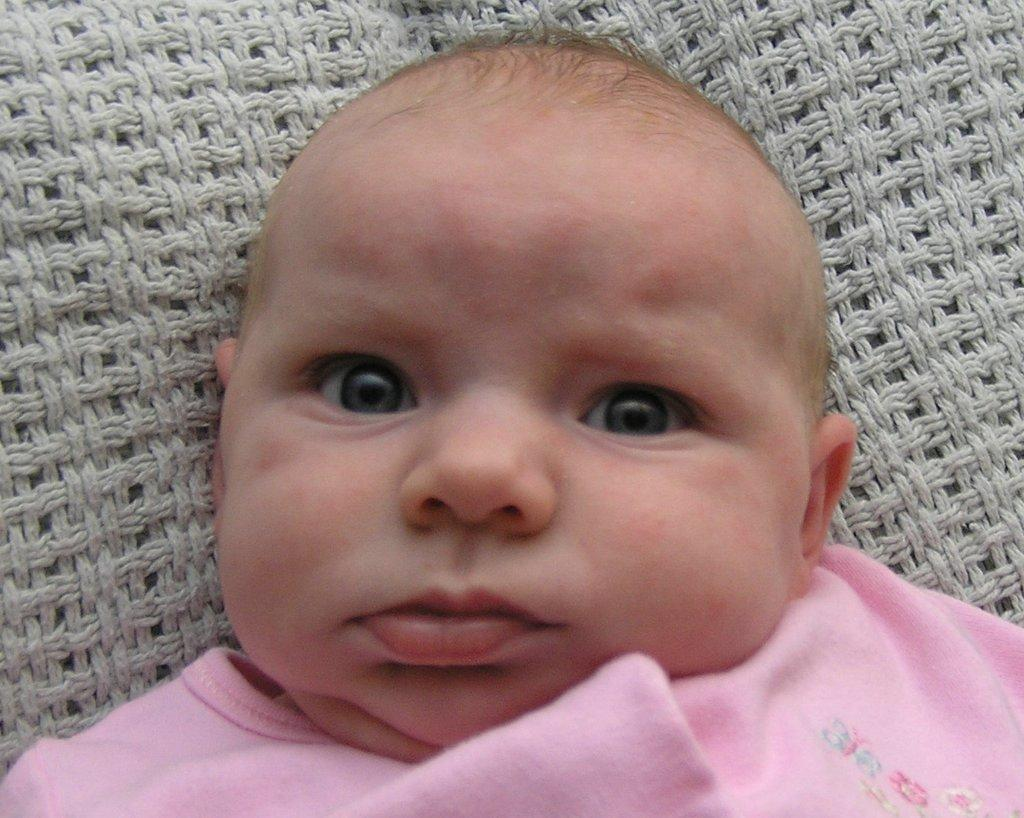What is the main subject of the image? There is a baby in the image. What color is the baby's clothing? The baby is wearing pink clothing. What is beneath the baby in the image? There is a cloth beneath the baby. What type of engine can be seen in the background of the image? There is no engine present in the image; it features a baby wearing pink clothing with a cloth beneath them. 